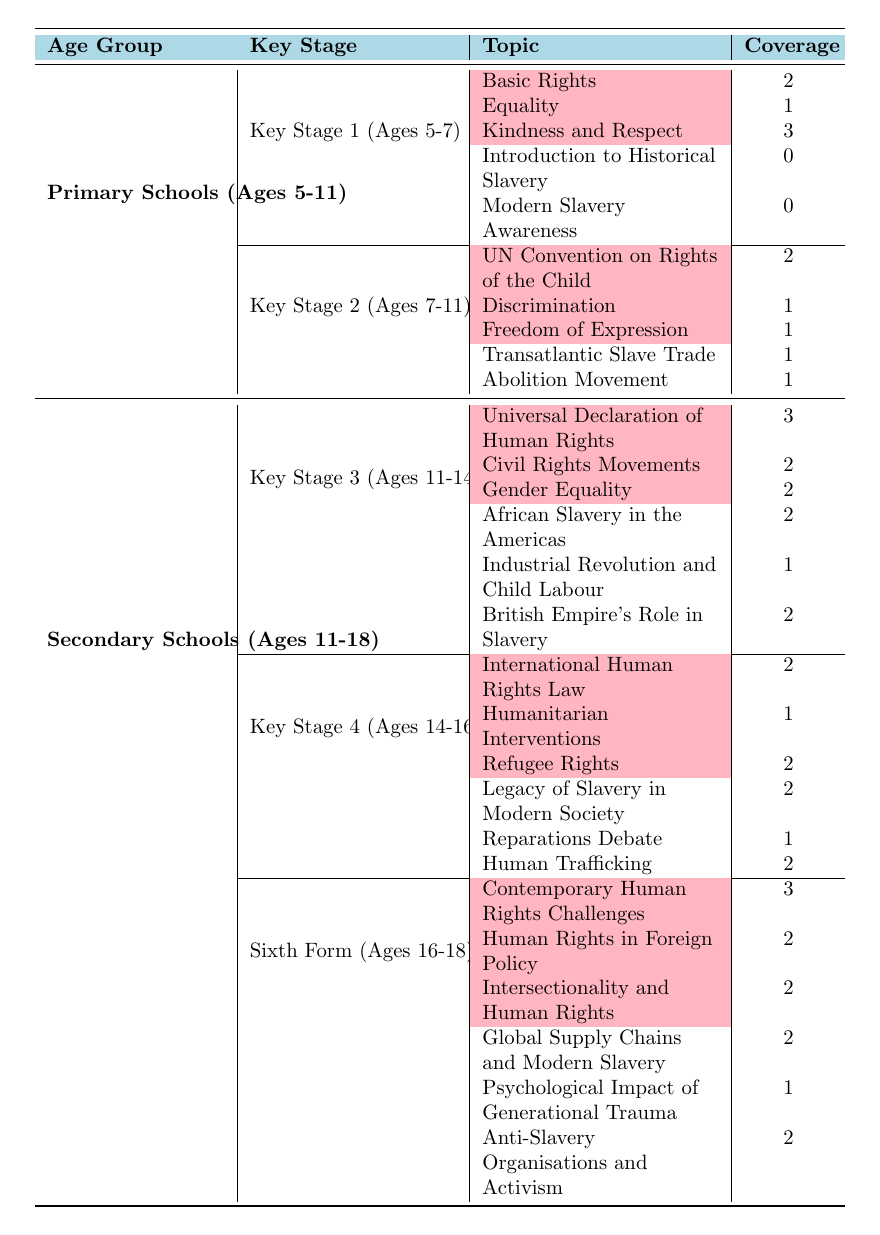What is the coverage of "Transatlantic Slave Trade" in Key Stage 2? The table indicates that in Key Stage 2 (Ages 7-11), "Transatlantic Slave Trade" has a coverage of 1.
Answer: 1 Which age group has the most comprehensive coverage of human rights topics? Reviewing the table, in the Sixth Form (Ages 16-18), there are 3 human rights topics with the highest coverage score of 3.
Answer: Sixth Form What is the total coverage of slavery topics in Key Stage 4? Adding the coverage for slavery topics in Key Stage 4 (Legacy of Slavery in Modern Society: 2, Reparations Debate: 1, Human Trafficking: 2) gives 2 + 1 + 2 = 5.
Answer: 5 Is there any coverage for "Modern Slavery Awareness" in Key Stage 1? According to the table, the coverage for "Modern Slavery Awareness" in Key Stage 1 is 0, implying no coverage.
Answer: No What is the total number of human rights topics covered across all age groups? Counting all human rights topics: Key Stage 1 has 3, Key Stage 2 has 3, Key Stage 3 has 3, Key Stage 4 has 3, and Sixth Form has 3 for a total of 3 + 3 + 3 + 3 + 3 = 15.
Answer: 15 Which Key Stage has the least focus on slavery topics? By evaluating the coverage in each Key Stage, Key Stage 1 in Primary Schools has no coverage (0 for both topics).
Answer: Key Stage 1 What is the average coverage of human rights topics in Key Stage 3? The sum of human rights topic coverage in Key Stage 3 (Universal Declaration of Human Rights: 3, Civil Rights Movements: 2, Gender Equality: 2) is 3 + 2 + 2 = 7, and dividing by 3 topics gives 7/3 = 2.33.
Answer: 2.33 Are there more human rights topics than slavery topics in the Sixth Form? In Sixth Form, there are 3 human rights topics and 3 slavery topics, indicating they are equal.
Answer: No How many total slavery topics are covered in Secondary Schools? Summing up slavery topics in Key Stage 3 (3), Key Stage 4 (3), and Sixth Form (3) gives a total of 3 + 3 + 3 = 9.
Answer: 9 What is the difference in coverage between "Kindness and Respect" and "Introduction to Historical Slavery" in Key Stage 1? The coverage for "Kindness and Respect" is 3, while "Introduction to Historical Slavery" has 0. The difference is 3 - 0 = 3.
Answer: 3 